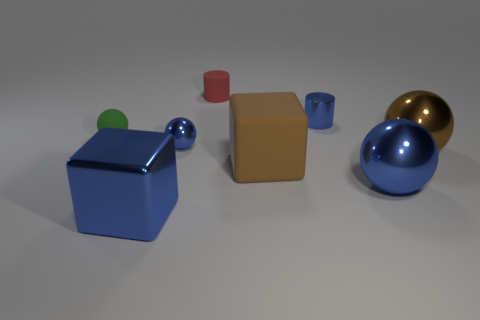Subtract 1 balls. How many balls are left? 3 Subtract all small blue balls. How many balls are left? 3 Add 1 tiny cyan cubes. How many objects exist? 9 Subtract all green spheres. How many spheres are left? 3 Subtract all cyan balls. Subtract all cyan blocks. How many balls are left? 4 Subtract all cylinders. How many objects are left? 6 Subtract 1 red cylinders. How many objects are left? 7 Subtract all cylinders. Subtract all tiny purple cylinders. How many objects are left? 6 Add 6 small balls. How many small balls are left? 8 Add 8 big blue things. How many big blue things exist? 10 